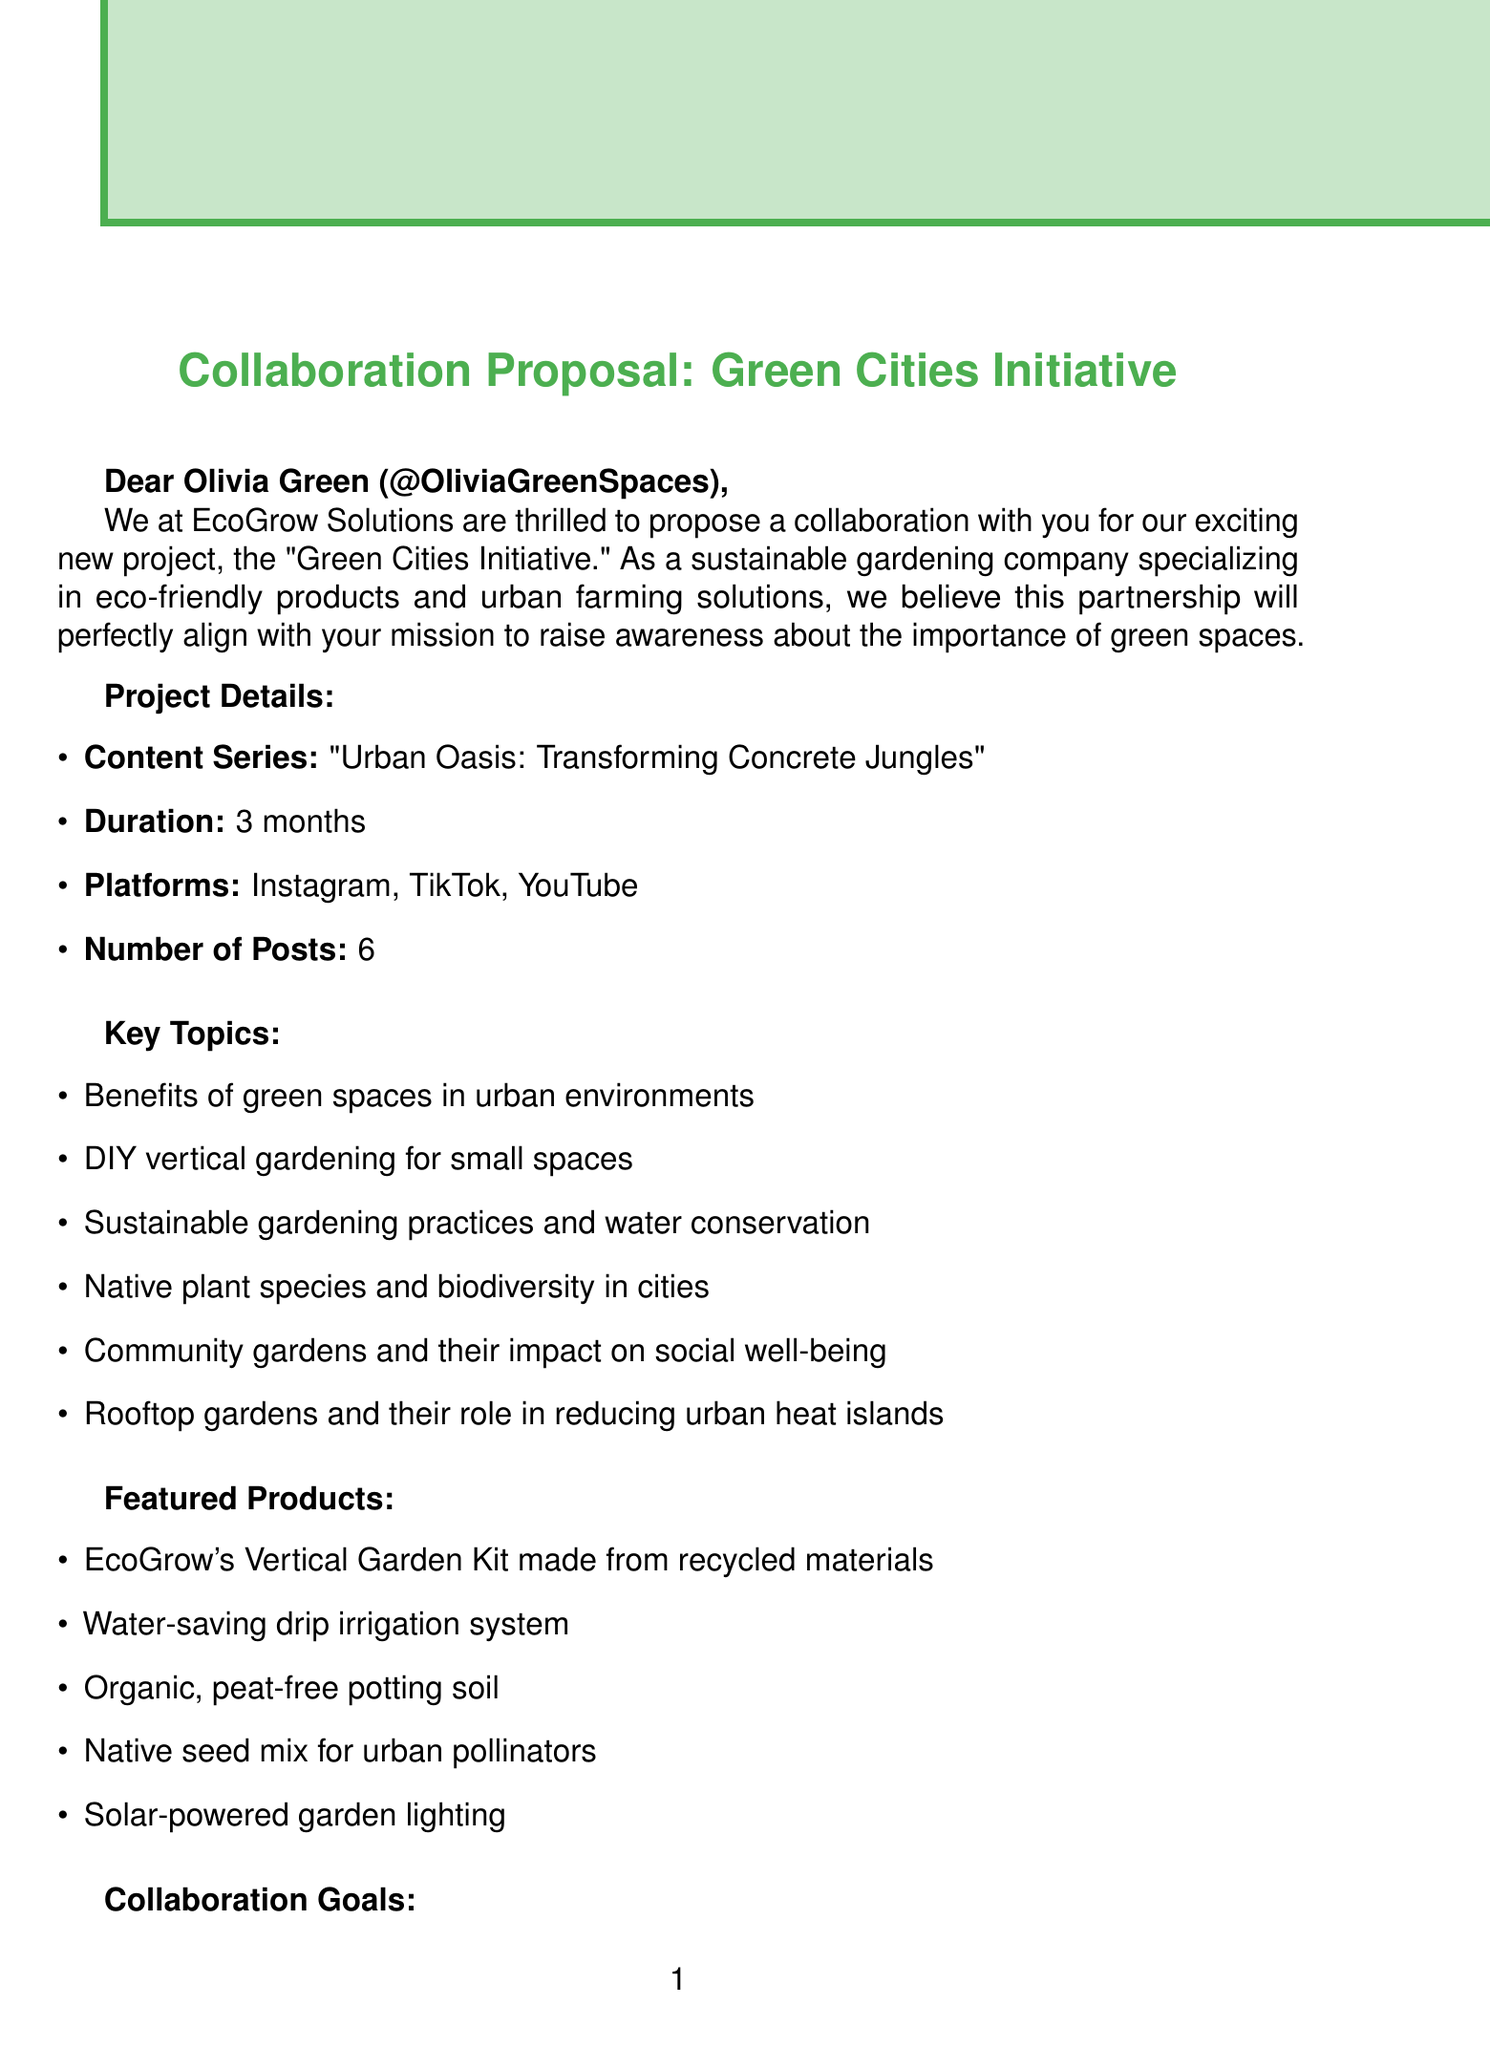What is the project name? The project name is specifically mentioned as "Green Cities Initiative."
Answer: Green Cities Initiative How many posts are included in the content series? The document states that the number of posts is 6, as outlined in the project details.
Answer: 6 What sustainable product features are mentioned? The document lists various product features, including the "EcoGrow's Vertical Garden Kit made from recycled materials."
Answer: EcoGrow's Vertical Garden Kit made from recycled materials What is the duration of the collaboration? The duration of the collaboration is specified to be 3 months in the project details section.
Answer: 3 months What is the monetary compensation per month? The letter states that the monetary compensation is $5,000 per month.
Answer: $5,000 Which platform is not included in the collaboration? The document lists Instagram, TikTok, and YouTube as the included platforms, leaving out others like Facebook.
Answer: Facebook What is the primary goal of the collaboration? The goals include increasing awareness about the importance of green spaces in cities.
Answer: Increase awareness about the importance of green spaces in cities Who are potential partners mentioned in the letter? Mentioned potential partners include local community gardens and environmental nonprofits, among others.
Answer: Local community gardens (e.g., Brooklyn Grange) 